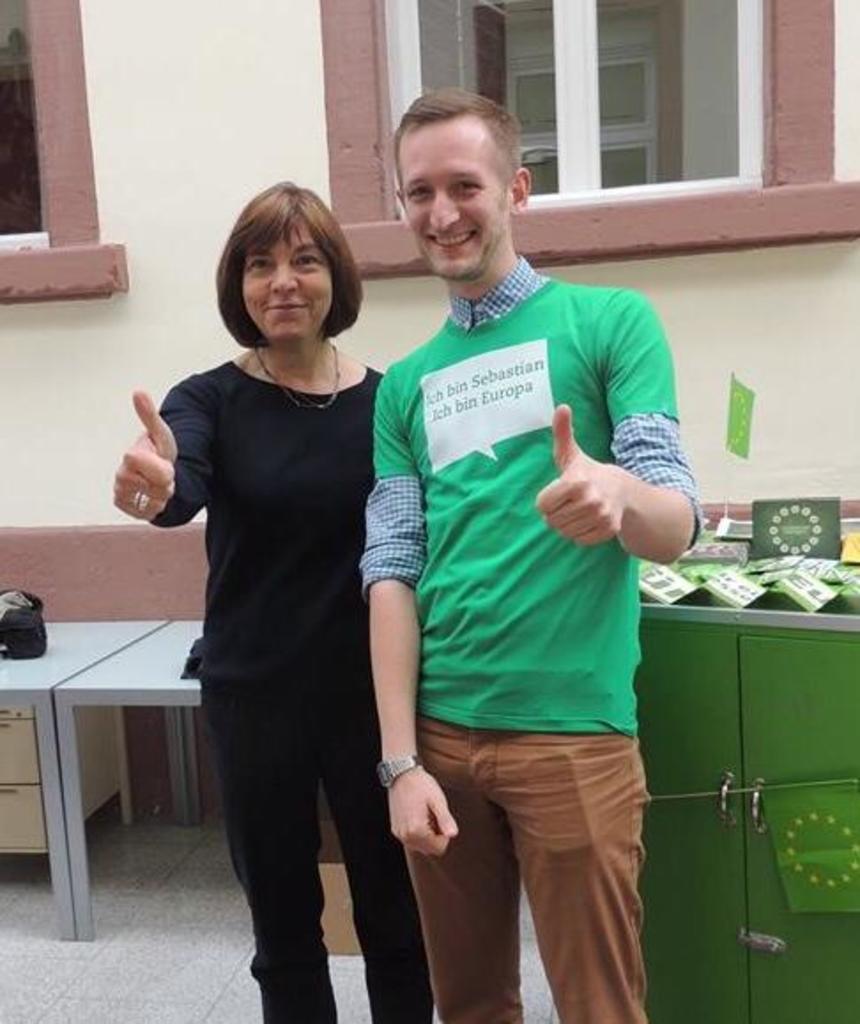How would you summarize this image in a sentence or two? In this image in the center there is one man and one woman standing and they are smiling, and in the background there are tables. On the tables there are some cards and boards, and objects. At the bottom there is floor, and in the background there is a box and there are windows and wall. 